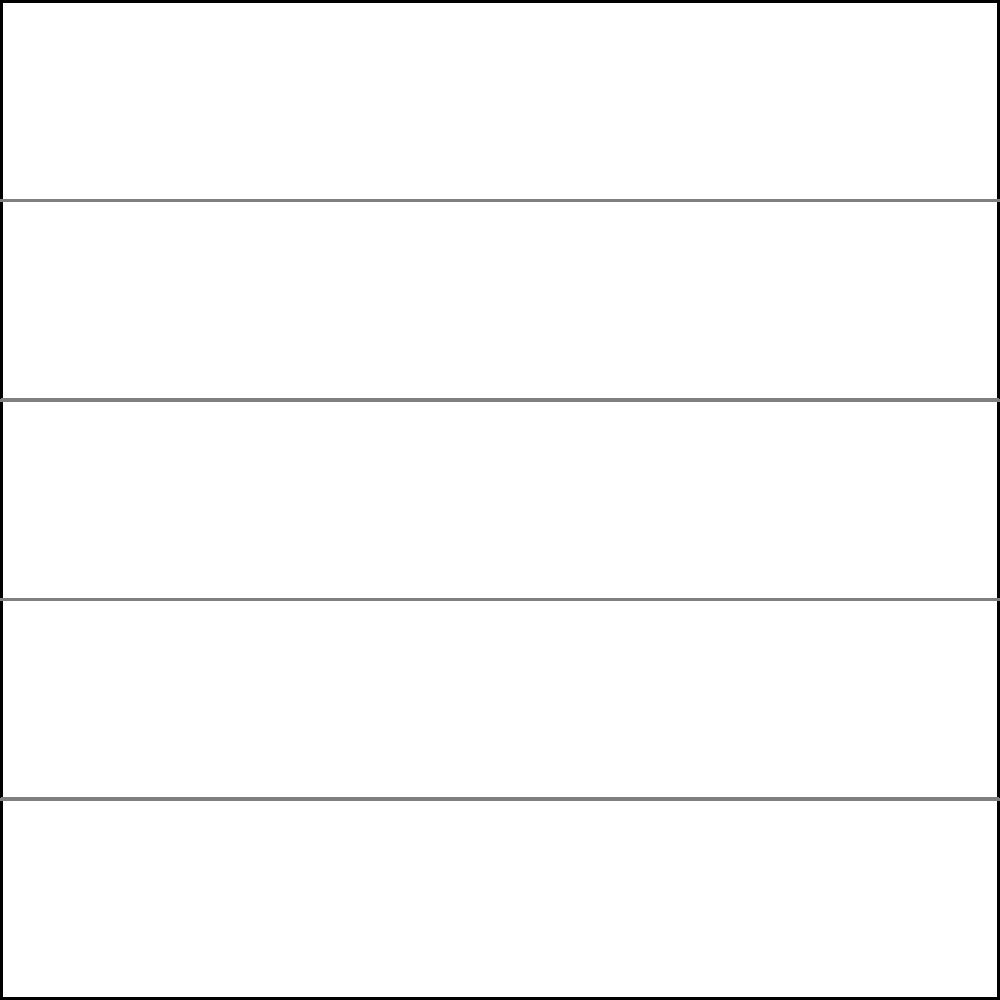Based on the layout of amenities in this 5-story office building, which floor would be the most strategic location for a new collaborative workspace to maximize accessibility and minimize travel time for employees? To determine the most strategic location for a new collaborative workspace, we need to consider the following factors:

1. Central location: The ideal floor should be centrally located to minimize overall travel time for employees from all floors.

2. Existing amenities: We should consider the distribution of current amenities to ensure the new workspace complements them without overcrowding any particular floor.

3. Floor traffic: A floor with moderate existing amenities might be preferable to balance usage and avoid congestion.

Let's analyze each floor:

1. Ground Floor: Has a cafe, which is a high-traffic area. It might be too busy for a collaborative workspace.
2. 2nd Floor: Contains a gym, which is a specialized amenity and doesn't generate constant traffic.
3. 3rd Floor: Has meeting rooms, which suggests it's already designed for collaboration.
4. 4th Floor: Contains a lounge, which is a more casual space.
5. 5th Floor: Has a rooftop garden, which is a specialized amenity.

The 3rd floor emerges as the most strategic location because:

1. It's centrally located, minimizing travel time from other floors.
2. It already has meeting rooms, indicating it's designed for collaborative work.
3. Adding a collaborative workspace here would create a "collaboration hub," increasing efficiency.
4. It's not overcrowded with amenities, allowing space for the new workspace.
5. It's equidistant from the busy ground floor and the quieter top floors, providing a good balance.

Therefore, the 3rd floor would be the most strategic location for the new collaborative workspace.
Answer: 3rd Floor 